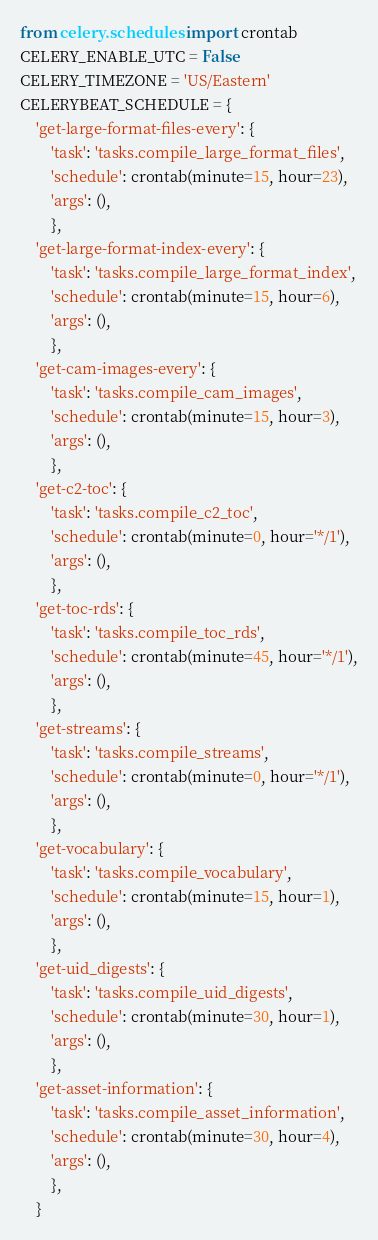<code> <loc_0><loc_0><loc_500><loc_500><_Python_>from celery.schedules import crontab
CELERY_ENABLE_UTC = False
CELERY_TIMEZONE = 'US/Eastern'
CELERYBEAT_SCHEDULE = {
    'get-large-format-files-every': {
        'task': 'tasks.compile_large_format_files',
        'schedule': crontab(minute=15, hour=23),
        'args': (),
        },
    'get-large-format-index-every': {
        'task': 'tasks.compile_large_format_index',
        'schedule': crontab(minute=15, hour=6),
        'args': (),
        },
    'get-cam-images-every': {
        'task': 'tasks.compile_cam_images',
        'schedule': crontab(minute=15, hour=3),
        'args': (),
        },
    'get-c2-toc': {
        'task': 'tasks.compile_c2_toc',
        'schedule': crontab(minute=0, hour='*/1'),
        'args': (),
        },
    'get-toc-rds': {
        'task': 'tasks.compile_toc_rds',
        'schedule': crontab(minute=45, hour='*/1'),
        'args': (),
        },
    'get-streams': {
        'task': 'tasks.compile_streams',
        'schedule': crontab(minute=0, hour='*/1'),
        'args': (),
        },
    'get-vocabulary': {
        'task': 'tasks.compile_vocabulary',
        'schedule': crontab(minute=15, hour=1),
        'args': (),
        },
    'get-uid_digests': {
        'task': 'tasks.compile_uid_digests',
        'schedule': crontab(minute=30, hour=1),
        'args': (),
        },
    'get-asset-information': {
        'task': 'tasks.compile_asset_information',
        'schedule': crontab(minute=30, hour=4),
        'args': (),
        },
    }</code> 